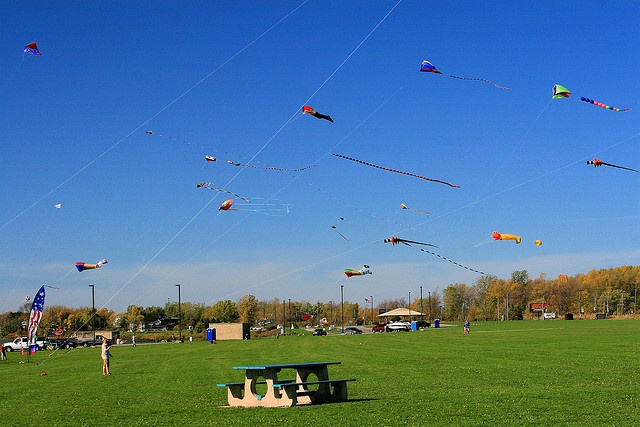Describe the objects in this image and their specific colors. I can see kite in blue and gray tones, bench in blue, black, tan, and darkgreen tones, dining table in blue, black, tan, and darkgreen tones, kite in blue, gray, maroon, and lightblue tones, and truck in blue, lightgray, black, darkgray, and gray tones in this image. 